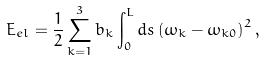<formula> <loc_0><loc_0><loc_500><loc_500>E _ { e l } = \frac { 1 } { 2 } \sum _ { k = 1 } ^ { 3 } b _ { k } \int _ { 0 } ^ { L } d s \left ( \omega _ { k } - \omega _ { k 0 } \right ) ^ { 2 } ,</formula> 